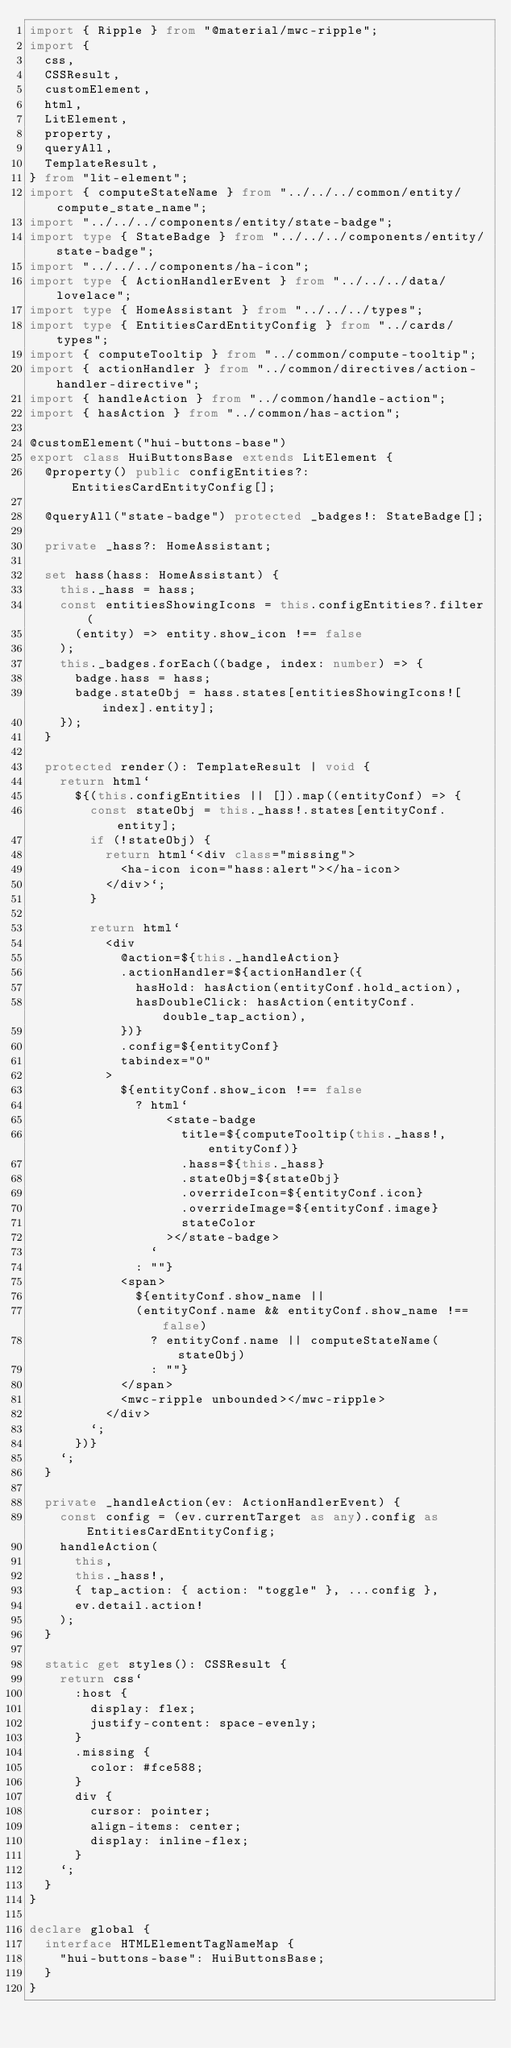<code> <loc_0><loc_0><loc_500><loc_500><_TypeScript_>import { Ripple } from "@material/mwc-ripple";
import {
  css,
  CSSResult,
  customElement,
  html,
  LitElement,
  property,
  queryAll,
  TemplateResult,
} from "lit-element";
import { computeStateName } from "../../../common/entity/compute_state_name";
import "../../../components/entity/state-badge";
import type { StateBadge } from "../../../components/entity/state-badge";
import "../../../components/ha-icon";
import type { ActionHandlerEvent } from "../../../data/lovelace";
import type { HomeAssistant } from "../../../types";
import type { EntitiesCardEntityConfig } from "../cards/types";
import { computeTooltip } from "../common/compute-tooltip";
import { actionHandler } from "../common/directives/action-handler-directive";
import { handleAction } from "../common/handle-action";
import { hasAction } from "../common/has-action";

@customElement("hui-buttons-base")
export class HuiButtonsBase extends LitElement {
  @property() public configEntities?: EntitiesCardEntityConfig[];

  @queryAll("state-badge") protected _badges!: StateBadge[];

  private _hass?: HomeAssistant;

  set hass(hass: HomeAssistant) {
    this._hass = hass;
    const entitiesShowingIcons = this.configEntities?.filter(
      (entity) => entity.show_icon !== false
    );
    this._badges.forEach((badge, index: number) => {
      badge.hass = hass;
      badge.stateObj = hass.states[entitiesShowingIcons![index].entity];
    });
  }

  protected render(): TemplateResult | void {
    return html`
      ${(this.configEntities || []).map((entityConf) => {
        const stateObj = this._hass!.states[entityConf.entity];
        if (!stateObj) {
          return html`<div class="missing">
            <ha-icon icon="hass:alert"></ha-icon>
          </div>`;
        }

        return html`
          <div
            @action=${this._handleAction}
            .actionHandler=${actionHandler({
              hasHold: hasAction(entityConf.hold_action),
              hasDoubleClick: hasAction(entityConf.double_tap_action),
            })}
            .config=${entityConf}
            tabindex="0"
          >
            ${entityConf.show_icon !== false
              ? html`
                  <state-badge
                    title=${computeTooltip(this._hass!, entityConf)}
                    .hass=${this._hass}
                    .stateObj=${stateObj}
                    .overrideIcon=${entityConf.icon}
                    .overrideImage=${entityConf.image}
                    stateColor
                  ></state-badge>
                `
              : ""}
            <span>
              ${entityConf.show_name ||
              (entityConf.name && entityConf.show_name !== false)
                ? entityConf.name || computeStateName(stateObj)
                : ""}
            </span>
            <mwc-ripple unbounded></mwc-ripple>
          </div>
        `;
      })}
    `;
  }

  private _handleAction(ev: ActionHandlerEvent) {
    const config = (ev.currentTarget as any).config as EntitiesCardEntityConfig;
    handleAction(
      this,
      this._hass!,
      { tap_action: { action: "toggle" }, ...config },
      ev.detail.action!
    );
  }

  static get styles(): CSSResult {
    return css`
      :host {
        display: flex;
        justify-content: space-evenly;
      }
      .missing {
        color: #fce588;
      }
      div {
        cursor: pointer;
        align-items: center;
        display: inline-flex;
      }
    `;
  }
}

declare global {
  interface HTMLElementTagNameMap {
    "hui-buttons-base": HuiButtonsBase;
  }
}
</code> 